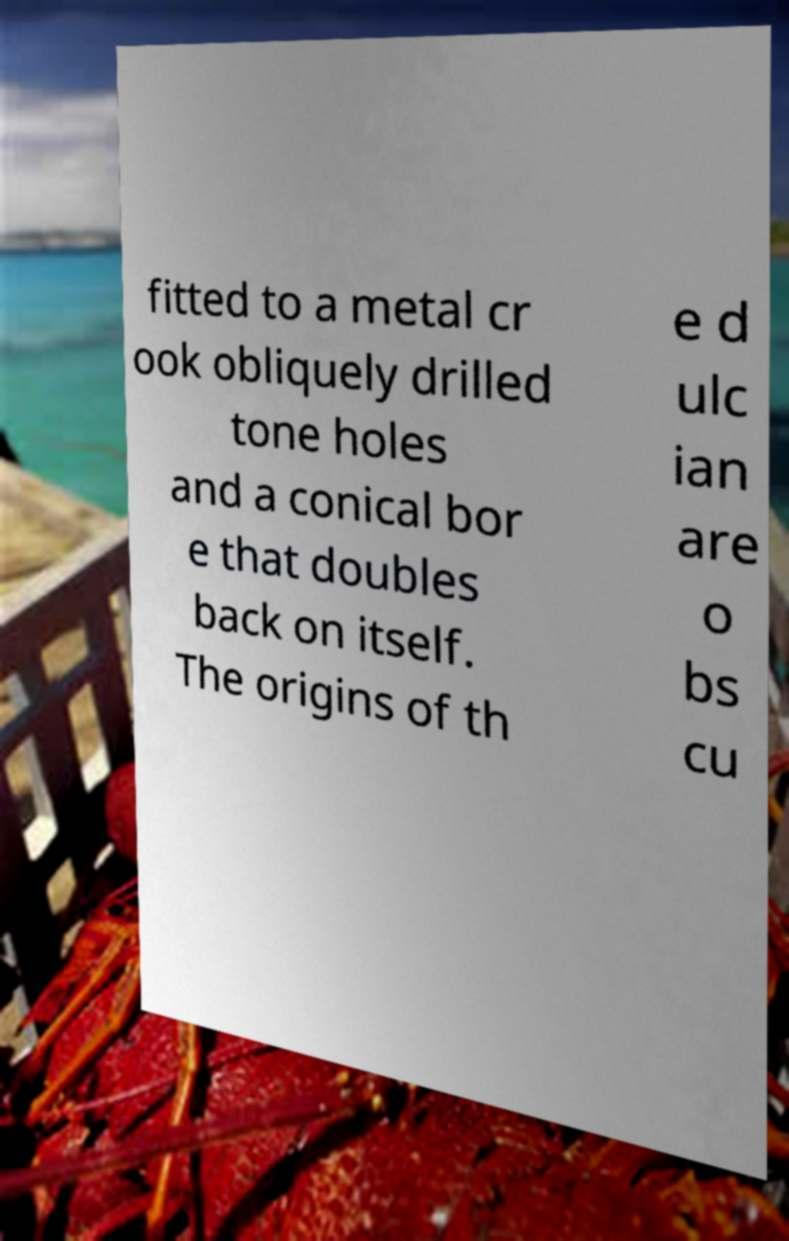I need the written content from this picture converted into text. Can you do that? fitted to a metal cr ook obliquely drilled tone holes and a conical bor e that doubles back on itself. The origins of th e d ulc ian are o bs cu 